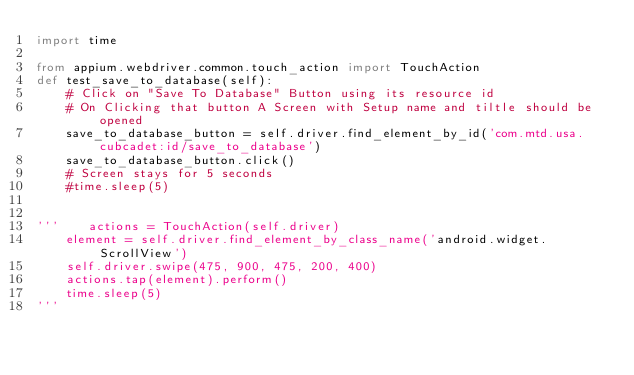<code> <loc_0><loc_0><loc_500><loc_500><_Python_>import time

from appium.webdriver.common.touch_action import TouchAction
def test_save_to_database(self):
    # Click on "Save To Database" Button using its resource id
    # On Clicking that button A Screen with Setup name and tiltle should be opened
    save_to_database_button = self.driver.find_element_by_id('com.mtd.usa.cubcadet:id/save_to_database')
    save_to_database_button.click()
    # Screen stays for 5 seconds
    #time.sleep(5)


'''    actions = TouchAction(self.driver)
    element = self.driver.find_element_by_class_name('android.widget.ScrollView')
    self.driver.swipe(475, 900, 475, 200, 400)
    actions.tap(element).perform()
    time.sleep(5)
'''


</code> 